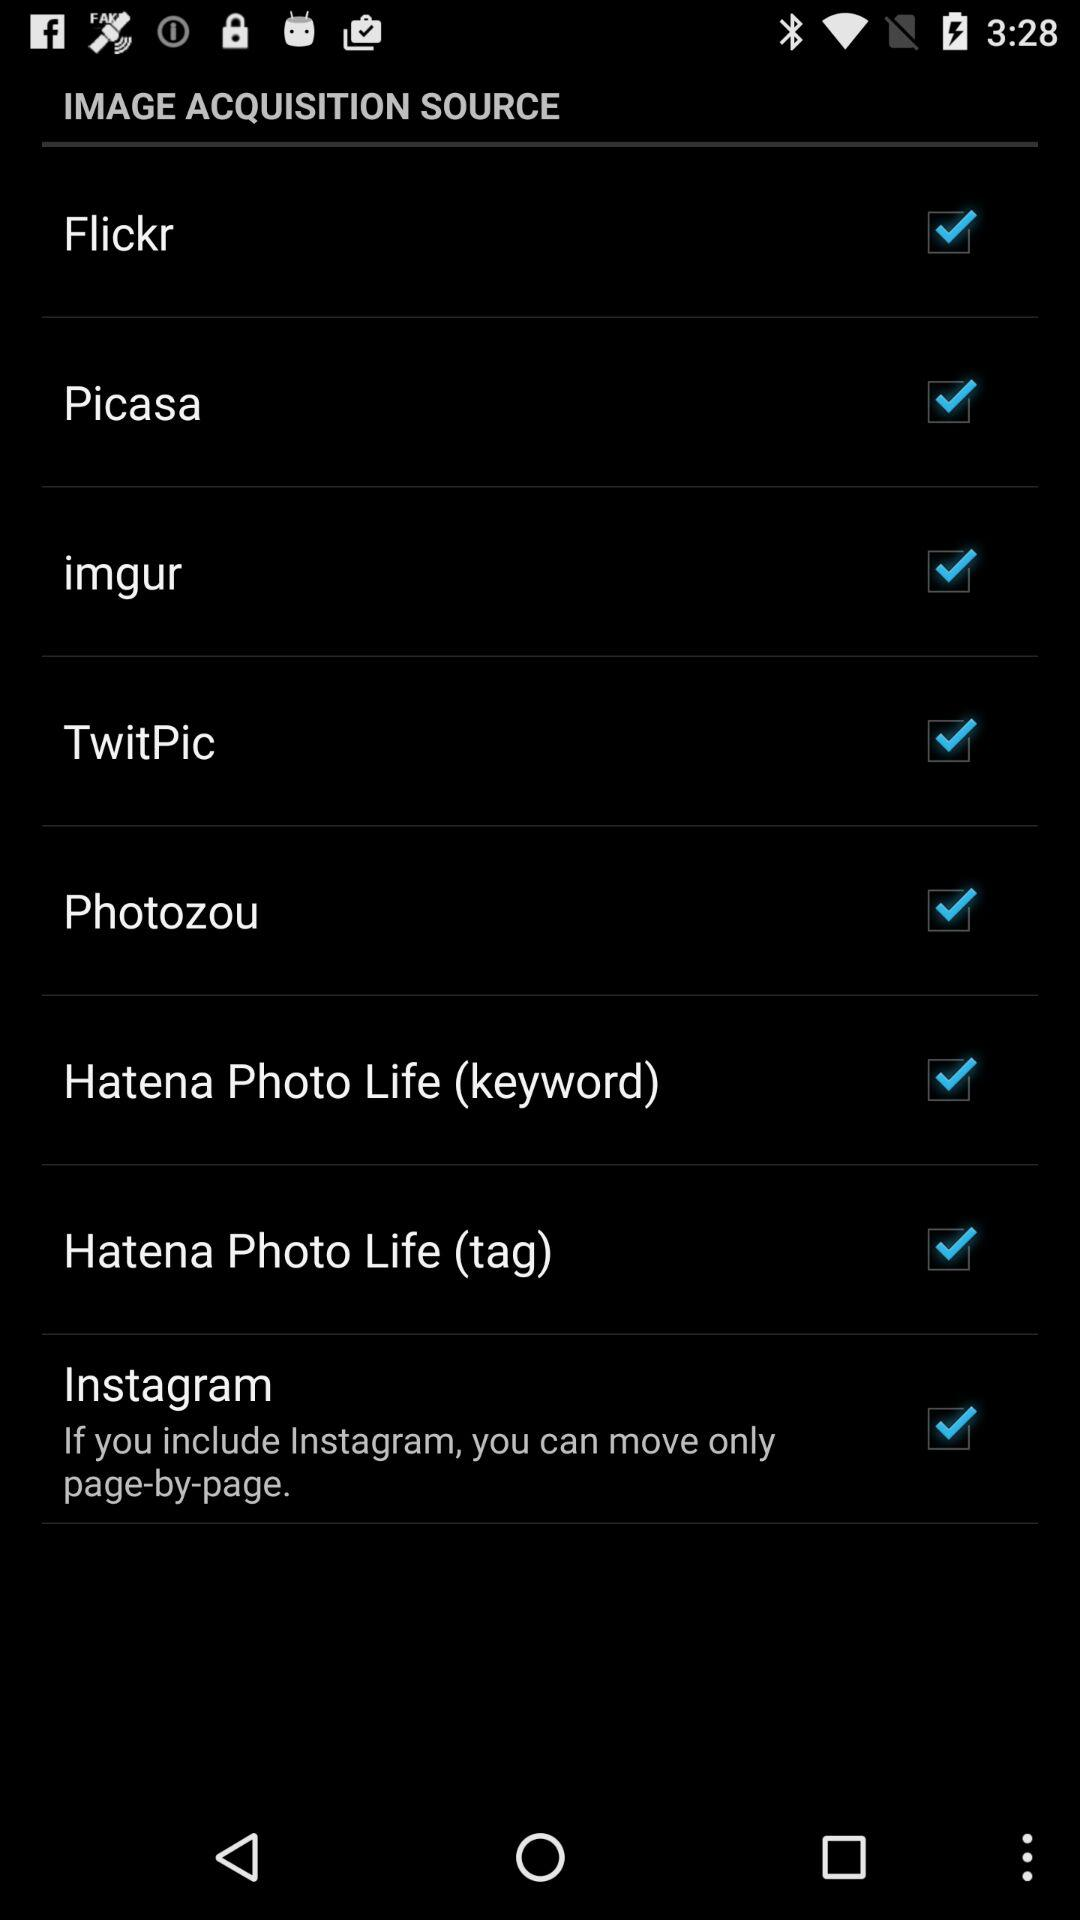What is the status of "Instagram"? The status of "Instagram" is "on". 